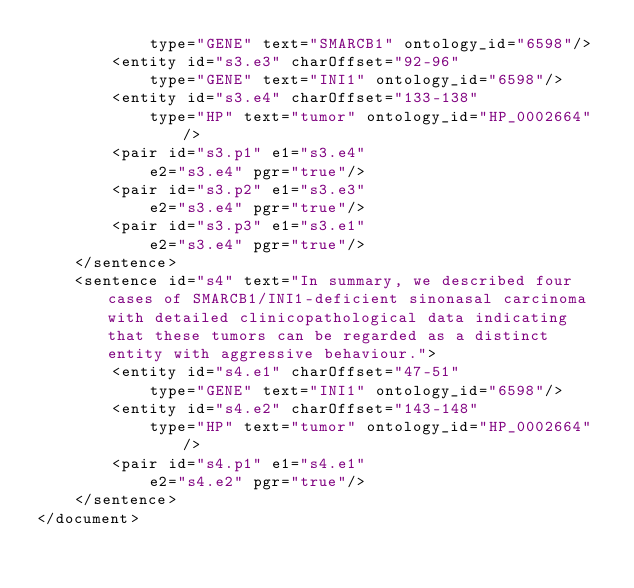Convert code to text. <code><loc_0><loc_0><loc_500><loc_500><_XML_>			type="GENE" text="SMARCB1" ontology_id="6598"/>
		<entity id="s3.e3" charOffset="92-96"
			type="GENE" text="INI1" ontology_id="6598"/>
		<entity id="s3.e4" charOffset="133-138"
			type="HP" text="tumor" ontology_id="HP_0002664"/>
		<pair id="s3.p1" e1="s3.e4"
		    e2="s3.e4" pgr="true"/>
		<pair id="s3.p2" e1="s3.e3"
		    e2="s3.e4" pgr="true"/>
		<pair id="s3.p3" e1="s3.e1"
		    e2="s3.e4" pgr="true"/>
	</sentence>
	<sentence id="s4" text="In summary, we described four cases of SMARCB1/INI1-deficient sinonasal carcinoma with detailed clinicopathological data indicating that these tumors can be regarded as a distinct entity with aggressive behaviour.">
		<entity id="s4.e1" charOffset="47-51"
			type="GENE" text="INI1" ontology_id="6598"/>
		<entity id="s4.e2" charOffset="143-148"
			type="HP" text="tumor" ontology_id="HP_0002664"/>
		<pair id="s4.p1" e1="s4.e1"
		    e2="s4.e2" pgr="true"/>
	</sentence>
</document>
</code> 